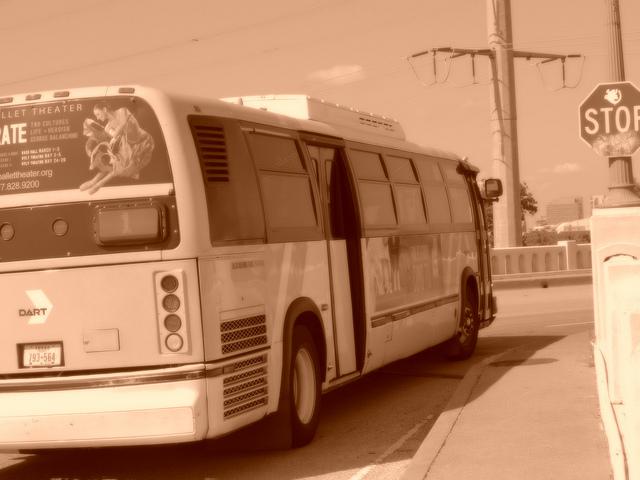How many windows does the bus have?
Answer briefly. 10. Is there enough space for this bus to turn on?
Concise answer only. Yes. Did the bus have to stop?
Concise answer only. Yes. 